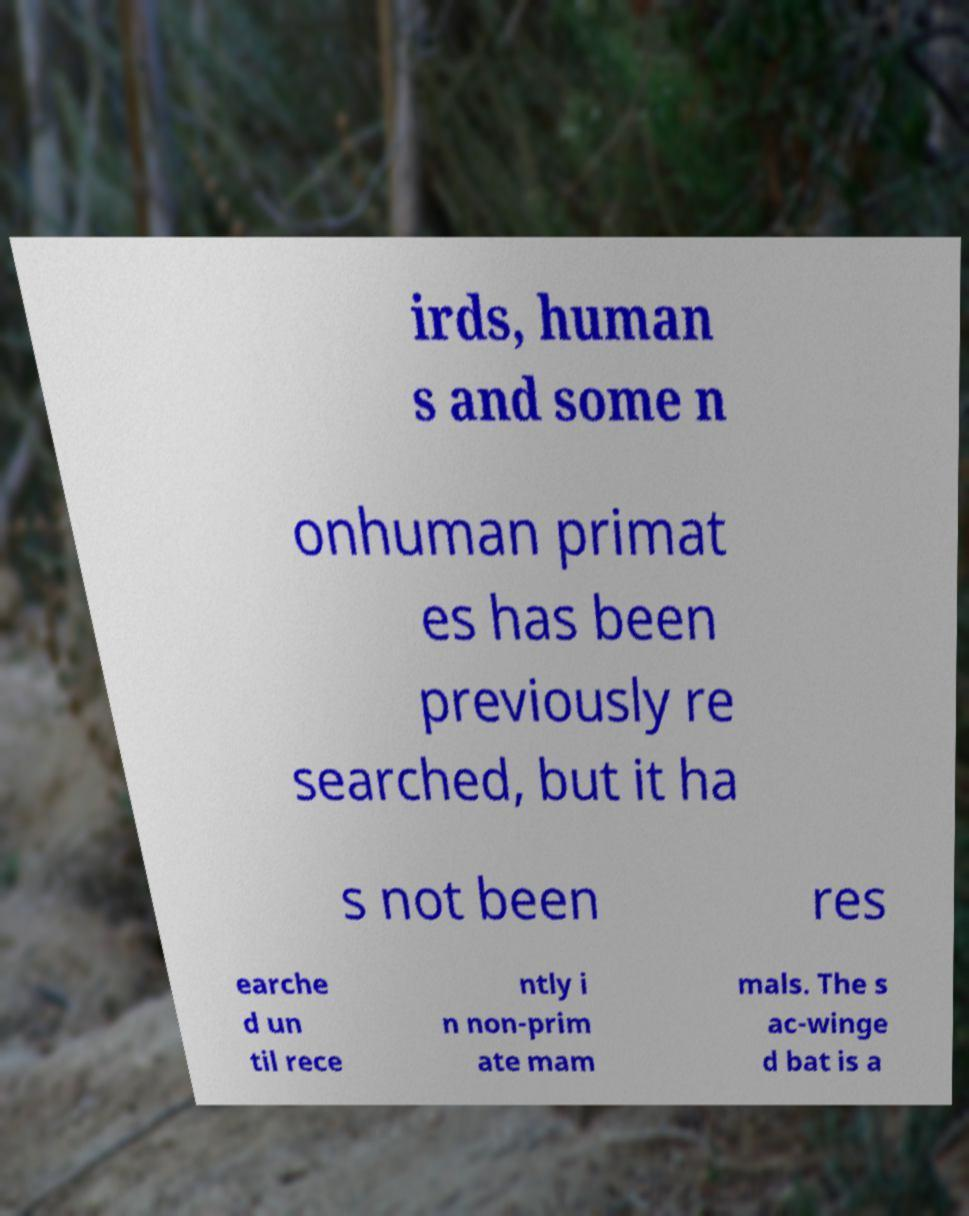Can you accurately transcribe the text from the provided image for me? irds, human s and some n onhuman primat es has been previously re searched, but it ha s not been res earche d un til rece ntly i n non-prim ate mam mals. The s ac-winge d bat is a 